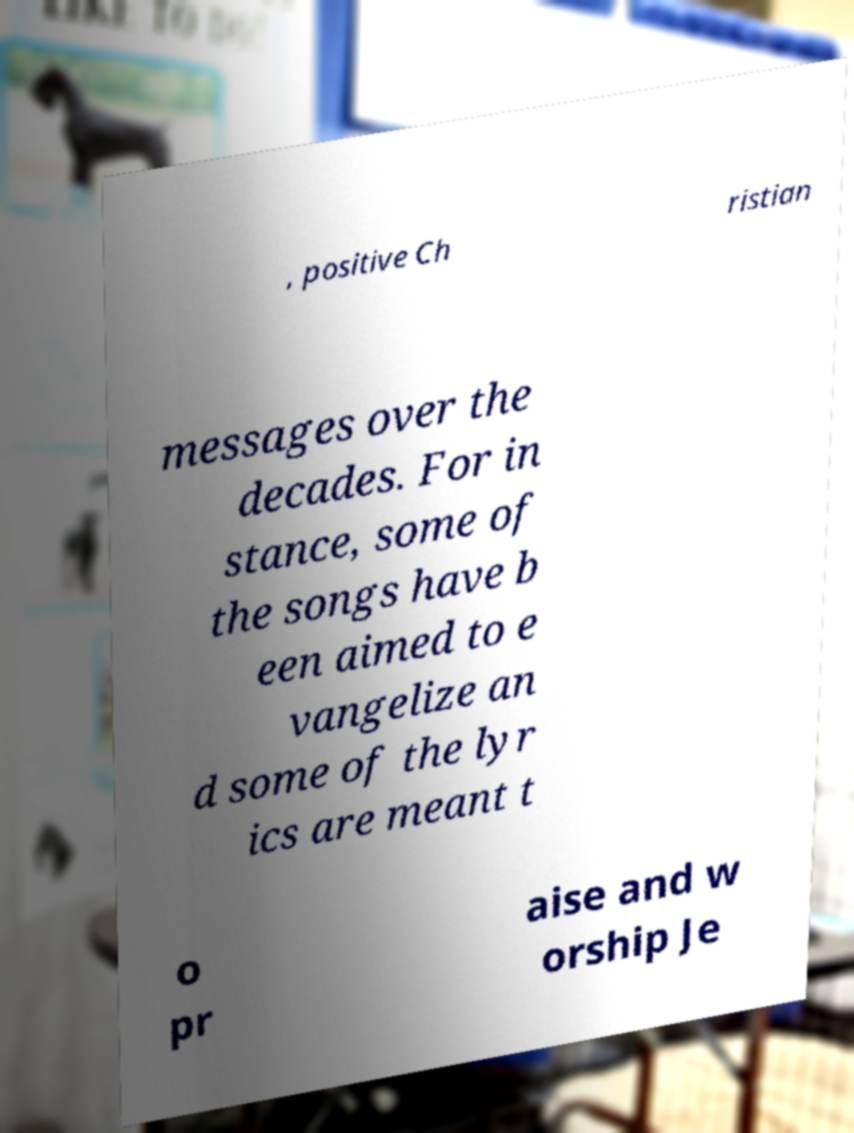There's text embedded in this image that I need extracted. Can you transcribe it verbatim? , positive Ch ristian messages over the decades. For in stance, some of the songs have b een aimed to e vangelize an d some of the lyr ics are meant t o pr aise and w orship Je 